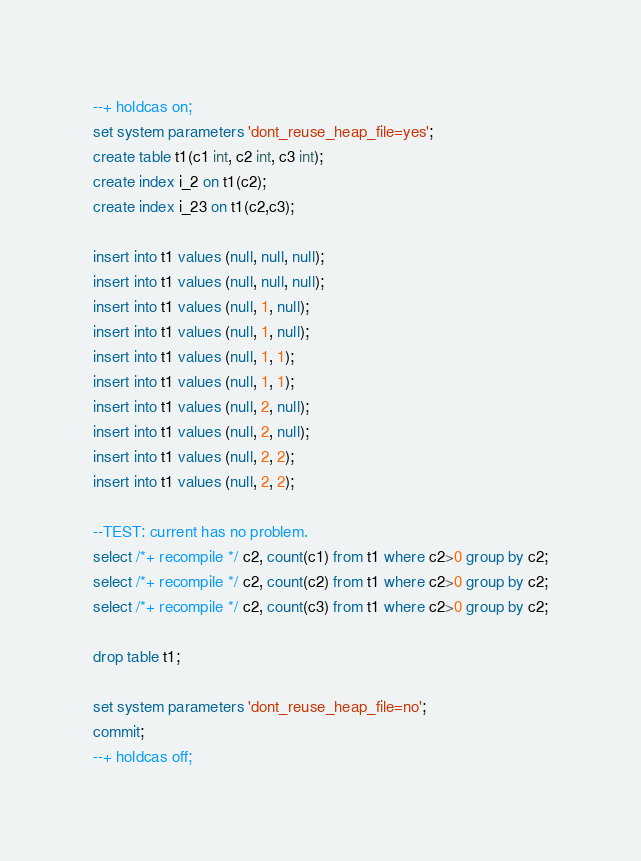Convert code to text. <code><loc_0><loc_0><loc_500><loc_500><_SQL_>--+ holdcas on;
set system parameters 'dont_reuse_heap_file=yes';
create table t1(c1 int, c2 int, c3 int);
create index i_2 on t1(c2);
create index i_23 on t1(c2,c3);

insert into t1 values (null, null, null);
insert into t1 values (null, null, null);
insert into t1 values (null, 1, null);
insert into t1 values (null, 1, null);
insert into t1 values (null, 1, 1);
insert into t1 values (null, 1, 1);
insert into t1 values (null, 2, null);
insert into t1 values (null, 2, null);
insert into t1 values (null, 2, 2);
insert into t1 values (null, 2, 2);

--TEST: current has no problem.
select /*+ recompile */ c2, count(c1) from t1 where c2>0 group by c2;
select /*+ recompile */ c2, count(c2) from t1 where c2>0 group by c2;
select /*+ recompile */ c2, count(c3) from t1 where c2>0 group by c2;

drop table t1;

set system parameters 'dont_reuse_heap_file=no';
commit;
--+ holdcas off;
</code> 